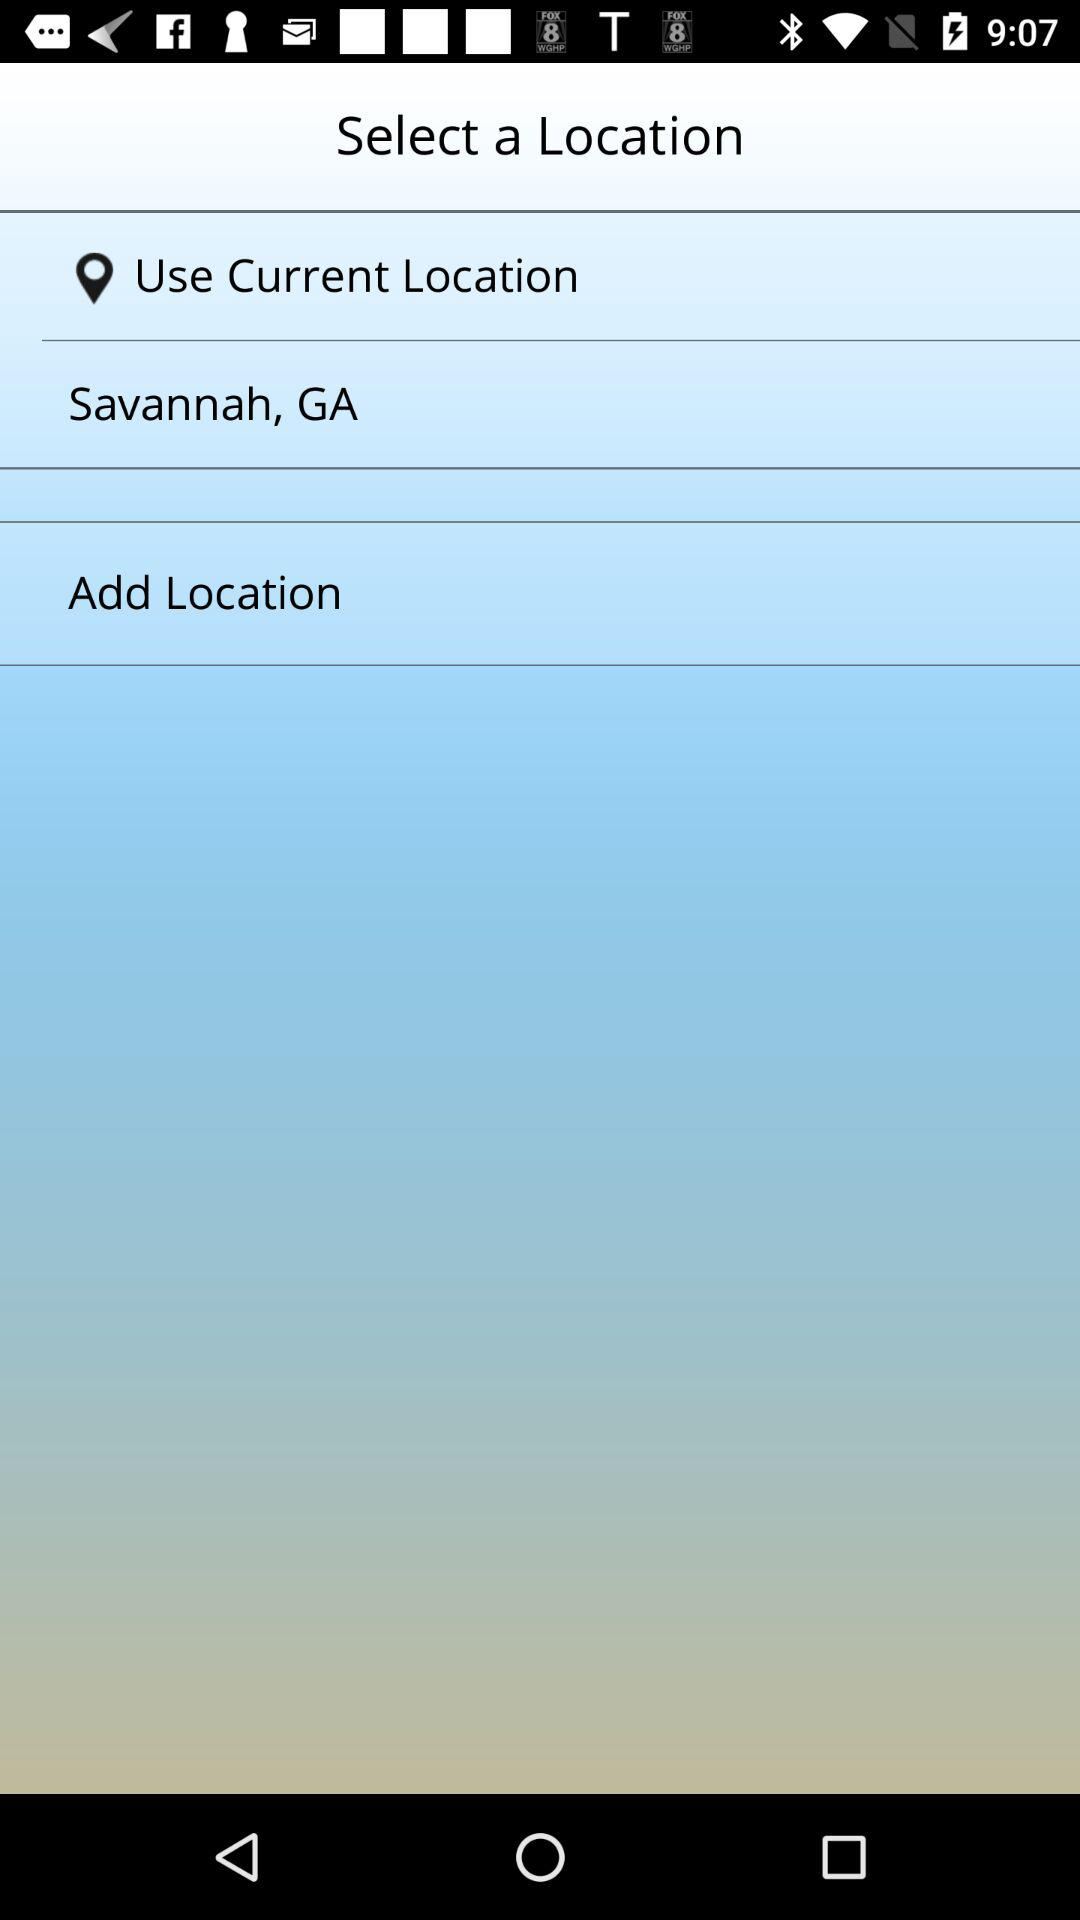What is the current location? The current location is Savannah, GA. 